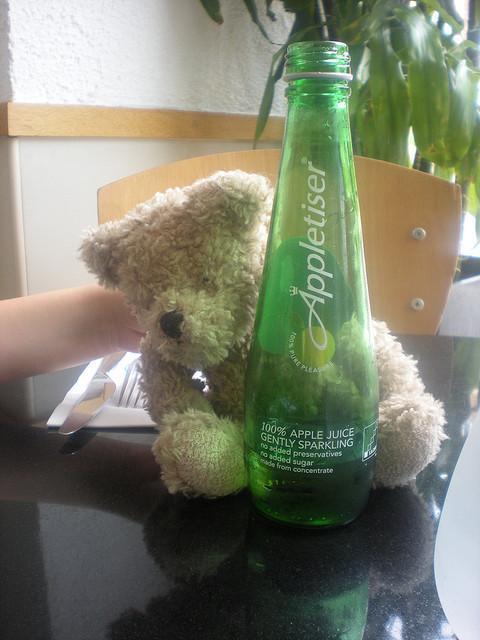How many people are wearing glasses?
Give a very brief answer. 0. 